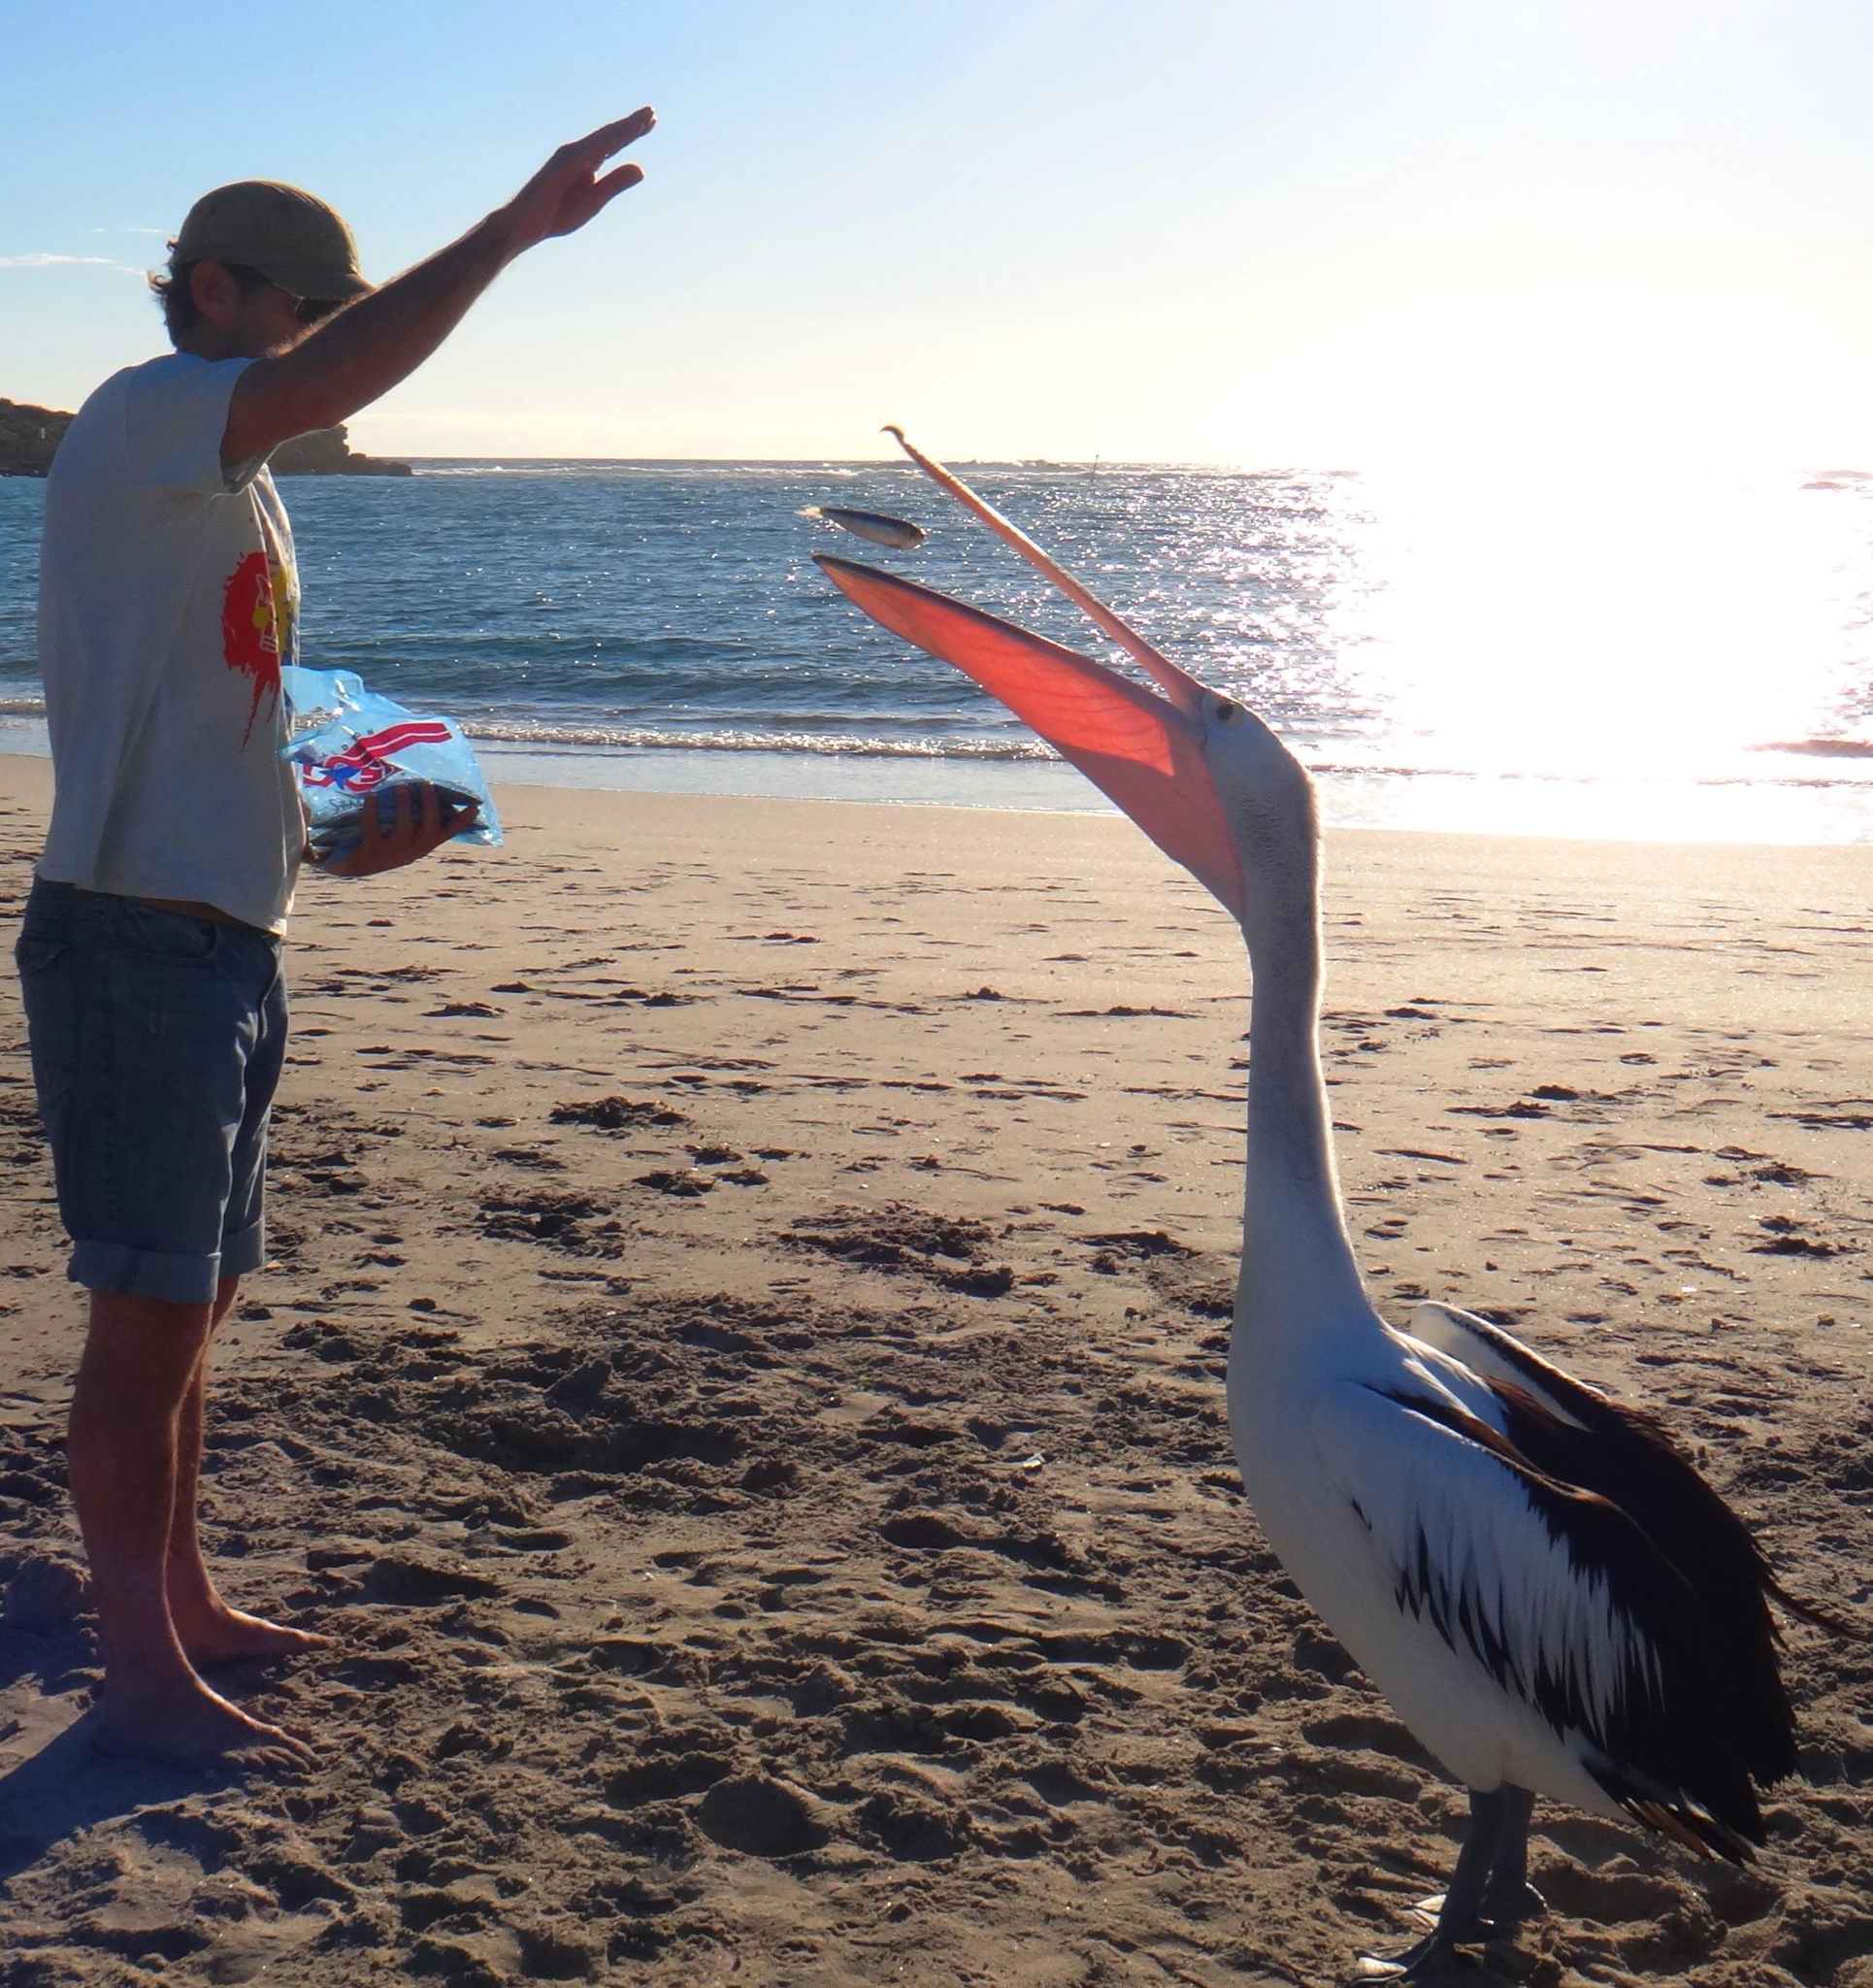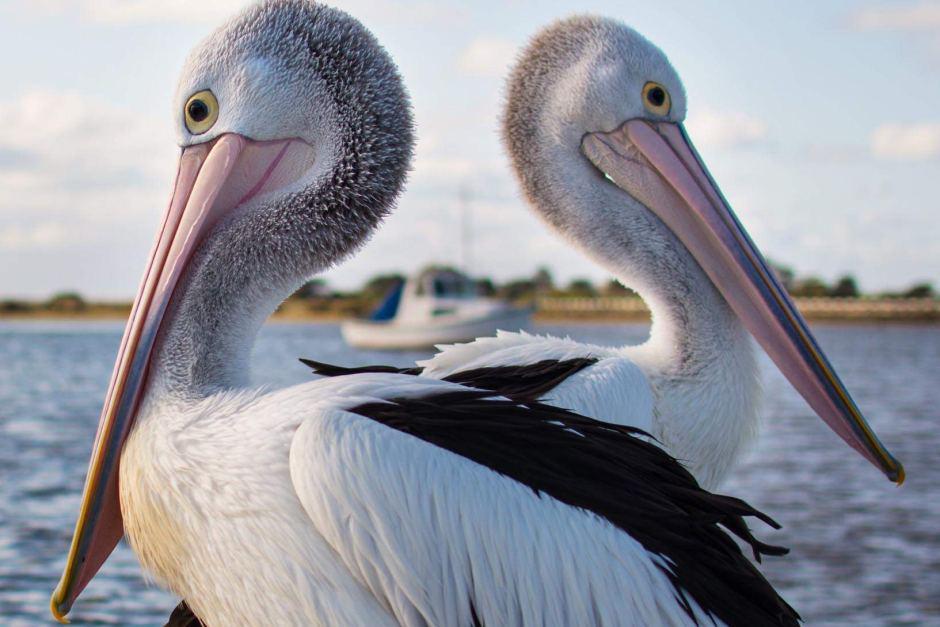The first image is the image on the left, the second image is the image on the right. Analyze the images presented: Is the assertion "There is a single human feeding a pelican with white and black feathers." valid? Answer yes or no. Yes. The first image is the image on the left, the second image is the image on the right. For the images shown, is this caption "There is no more than one bird on a beach in the left image." true? Answer yes or no. Yes. 